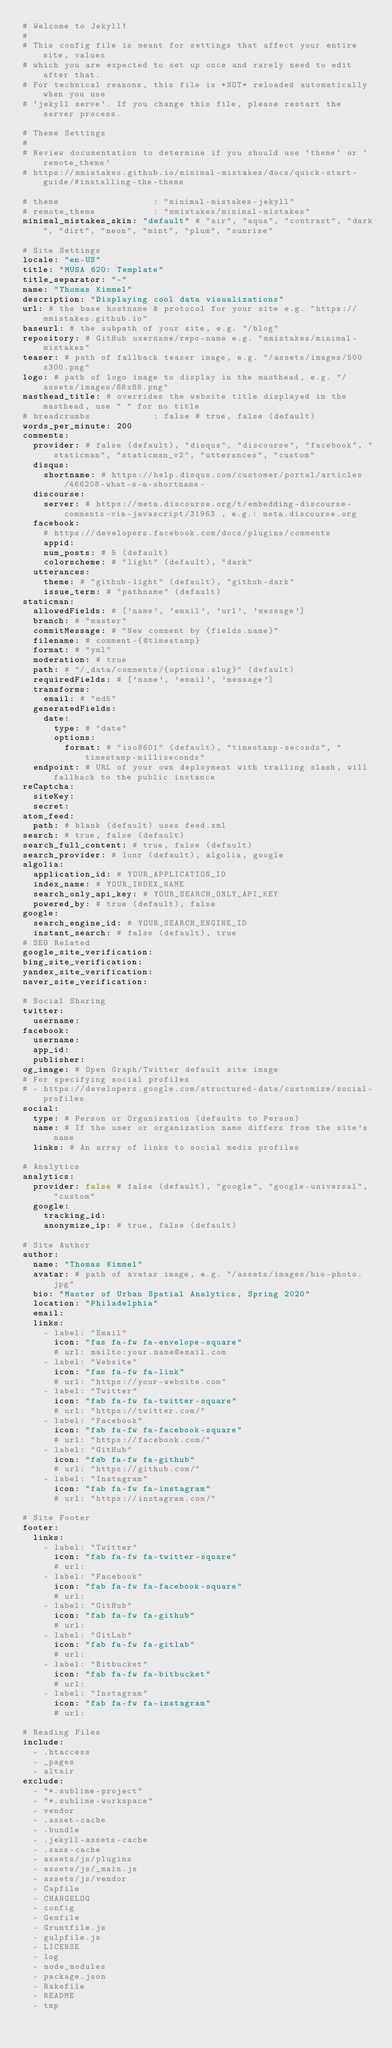<code> <loc_0><loc_0><loc_500><loc_500><_YAML_># Welcome to Jekyll!
#
# This config file is meant for settings that affect your entire site, values
# which you are expected to set up once and rarely need to edit after that.
# For technical reasons, this file is *NOT* reloaded automatically when you use
# `jekyll serve`. If you change this file, please restart the server process.

# Theme Settings
#
# Review documentation to determine if you should use `theme` or `remote_theme`
# https://mmistakes.github.io/minimal-mistakes/docs/quick-start-guide/#installing-the-theme

# theme                  : "minimal-mistakes-jekyll"
# remote_theme           : "mmistakes/minimal-mistakes"
minimal_mistakes_skin: "default" # "air", "aqua", "contrast", "dark", "dirt", "neon", "mint", "plum", "sunrise"

# Site Settings
locale: "en-US"
title: "MUSA 620: Template"
title_separator: "-"
name: "Thomas Kimmel"
description: "Displaying cool data visualizations"
url: # the base hostname & protocol for your site e.g. "https://mmistakes.github.io"
baseurl: # the subpath of your site, e.g. "/blog"
repository: # GitHub username/repo-name e.g. "mmistakes/minimal-mistakes"
teaser: # path of fallback teaser image, e.g. "/assets/images/500x300.png"
logo: # path of logo image to display in the masthead, e.g. "/assets/images/88x88.png"
masthead_title: # overrides the website title displayed in the masthead, use " " for no title
# breadcrumbs            : false # true, false (default)
words_per_minute: 200
comments:
  provider: # false (default), "disqus", "discourse", "facebook", "staticman", "staticman_v2", "utterances", "custom"
  disqus:
    shortname: # https://help.disqus.com/customer/portal/articles/466208-what-s-a-shortname-
  discourse:
    server: # https://meta.discourse.org/t/embedding-discourse-comments-via-javascript/31963 , e.g.: meta.discourse.org
  facebook:
    # https://developers.facebook.com/docs/plugins/comments
    appid:
    num_posts: # 5 (default)
    colorscheme: # "light" (default), "dark"
  utterances:
    theme: # "github-light" (default), "github-dark"
    issue_term: # "pathname" (default)
staticman:
  allowedFields: # ['name', 'email', 'url', 'message']
  branch: # "master"
  commitMessage: # "New comment by {fields.name}"
  filename: # comment-{@timestamp}
  format: # "yml"
  moderation: # true
  path: # "/_data/comments/{options.slug}" (default)
  requiredFields: # ['name', 'email', 'message']
  transforms:
    email: # "md5"
  generatedFields:
    date:
      type: # "date"
      options:
        format: # "iso8601" (default), "timestamp-seconds", "timestamp-milliseconds"
  endpoint: # URL of your own deployment with trailing slash, will fallback to the public instance
reCaptcha:
  siteKey:
  secret:
atom_feed:
  path: # blank (default) uses feed.xml
search: # true, false (default)
search_full_content: # true, false (default)
search_provider: # lunr (default), algolia, google
algolia:
  application_id: # YOUR_APPLICATION_ID
  index_name: # YOUR_INDEX_NAME
  search_only_api_key: # YOUR_SEARCH_ONLY_API_KEY
  powered_by: # true (default), false
google:
  search_engine_id: # YOUR_SEARCH_ENGINE_ID
  instant_search: # false (default), true
# SEO Related
google_site_verification:
bing_site_verification:
yandex_site_verification:
naver_site_verification:

# Social Sharing
twitter:
  username:
facebook:
  username:
  app_id:
  publisher:
og_image: # Open Graph/Twitter default site image
# For specifying social profiles
# - https://developers.google.com/structured-data/customize/social-profiles
social:
  type: # Person or Organization (defaults to Person)
  name: # If the user or organization name differs from the site's name
  links: # An array of links to social media profiles

# Analytics
analytics:
  provider: false # false (default), "google", "google-universal", "custom"
  google:
    tracking_id:
    anonymize_ip: # true, false (default)

# Site Author
author:
  name: "Thomas Kimmel"
  avatar: # path of avatar image, e.g. "/assets/images/bio-photo.jpg"
  bio: "Master of Urban Spatial Analytics, Spring 2020"
  location: "Philadelphia"
  email:
  links:
    - label: "Email"
      icon: "fas fa-fw fa-envelope-square"
      # url: mailto:your.name@email.com
    - label: "Website"
      icon: "fas fa-fw fa-link"
      # url: "https://your-website.com"
    - label: "Twitter"
      icon: "fab fa-fw fa-twitter-square"
      # url: "https://twitter.com/"
    - label: "Facebook"
      icon: "fab fa-fw fa-facebook-square"
      # url: "https://facebook.com/"
    - label: "GitHub"
      icon: "fab fa-fw fa-github"
      # url: "https://github.com/"
    - label: "Instagram"
      icon: "fab fa-fw fa-instagram"
      # url: "https://instagram.com/"

# Site Footer
footer:
  links:
    - label: "Twitter"
      icon: "fab fa-fw fa-twitter-square"
      # url:
    - label: "Facebook"
      icon: "fab fa-fw fa-facebook-square"
      # url:
    - label: "GitHub"
      icon: "fab fa-fw fa-github"
      # url:
    - label: "GitLab"
      icon: "fab fa-fw fa-gitlab"
      # url:
    - label: "Bitbucket"
      icon: "fab fa-fw fa-bitbucket"
      # url:
    - label: "Instagram"
      icon: "fab fa-fw fa-instagram"
      # url:

# Reading Files
include:
  - .htaccess
  - _pages
  - altair
exclude:
  - "*.sublime-project"
  - "*.sublime-workspace"
  - vendor
  - .asset-cache
  - .bundle
  - .jekyll-assets-cache
  - .sass-cache
  - assets/js/plugins
  - assets/js/_main.js
  - assets/js/vendor
  - Capfile
  - CHANGELOG
  - config
  - Gemfile
  - Gruntfile.js
  - gulpfile.js
  - LICENSE
  - log
  - node_modules
  - package.json
  - Rakefile
  - README
  - tmp</code> 